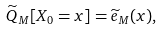Convert formula to latex. <formula><loc_0><loc_0><loc_500><loc_500>\widetilde { Q } _ { M } [ X _ { 0 } = x ] = \widetilde { e } _ { M } ( x ) ,</formula> 